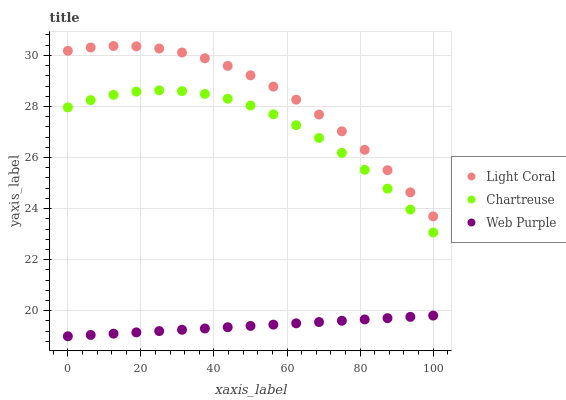Does Web Purple have the minimum area under the curve?
Answer yes or no. Yes. Does Light Coral have the maximum area under the curve?
Answer yes or no. Yes. Does Chartreuse have the minimum area under the curve?
Answer yes or no. No. Does Chartreuse have the maximum area under the curve?
Answer yes or no. No. Is Web Purple the smoothest?
Answer yes or no. Yes. Is Chartreuse the roughest?
Answer yes or no. Yes. Is Chartreuse the smoothest?
Answer yes or no. No. Is Web Purple the roughest?
Answer yes or no. No. Does Web Purple have the lowest value?
Answer yes or no. Yes. Does Chartreuse have the lowest value?
Answer yes or no. No. Does Light Coral have the highest value?
Answer yes or no. Yes. Does Chartreuse have the highest value?
Answer yes or no. No. Is Web Purple less than Light Coral?
Answer yes or no. Yes. Is Light Coral greater than Web Purple?
Answer yes or no. Yes. Does Web Purple intersect Light Coral?
Answer yes or no. No. 